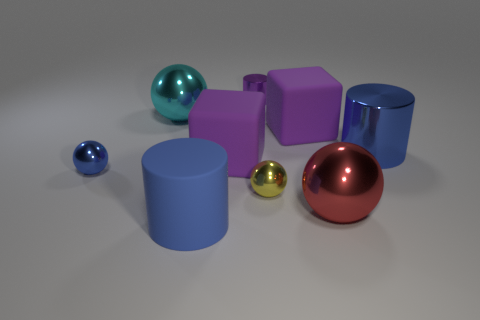There is another cylinder that is the same color as the matte cylinder; what is its material?
Offer a very short reply. Metal. Is the large ball to the left of the small purple object made of the same material as the object behind the cyan metallic ball?
Offer a terse response. Yes. There is a red thing that is the same size as the blue matte object; what is its shape?
Offer a very short reply. Sphere. Is there a tiny gray shiny thing that has the same shape as the tiny blue object?
Give a very brief answer. No. Does the large ball on the left side of the red metal ball have the same color as the object behind the cyan metallic sphere?
Make the answer very short. No. Are there any small purple things on the left side of the rubber cylinder?
Provide a short and direct response. No. There is a blue thing that is on the left side of the purple cylinder and behind the red metallic thing; what is it made of?
Make the answer very short. Metal. Is the material of the cube that is to the left of the tiny purple shiny thing the same as the small yellow object?
Provide a succinct answer. No. What material is the blue sphere?
Ensure brevity in your answer.  Metal. There is a cyan thing behind the blue rubber cylinder; what is its size?
Offer a terse response. Large. 